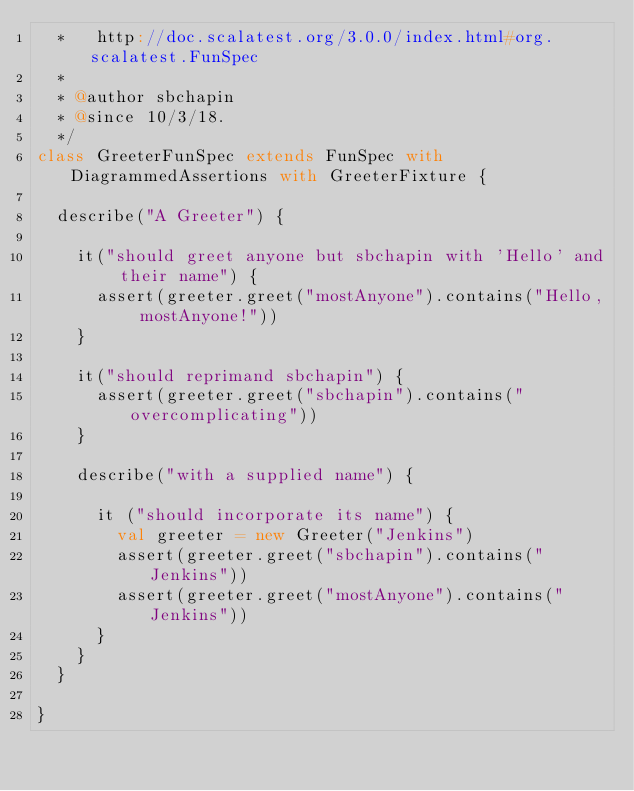<code> <loc_0><loc_0><loc_500><loc_500><_Scala_>  *   http://doc.scalatest.org/3.0.0/index.html#org.scalatest.FunSpec
  *
  * @author sbchapin
  * @since 10/3/18.
  */
class GreeterFunSpec extends FunSpec with DiagrammedAssertions with GreeterFixture {

  describe("A Greeter") {

    it("should greet anyone but sbchapin with 'Hello' and their name") {
      assert(greeter.greet("mostAnyone").contains("Hello, mostAnyone!"))
    }

    it("should reprimand sbchapin") {
      assert(greeter.greet("sbchapin").contains("overcomplicating"))
    }

    describe("with a supplied name") {

      it ("should incorporate its name") {
        val greeter = new Greeter("Jenkins")
        assert(greeter.greet("sbchapin").contains("Jenkins"))
        assert(greeter.greet("mostAnyone").contains("Jenkins"))
      }
    }
  }

}</code> 